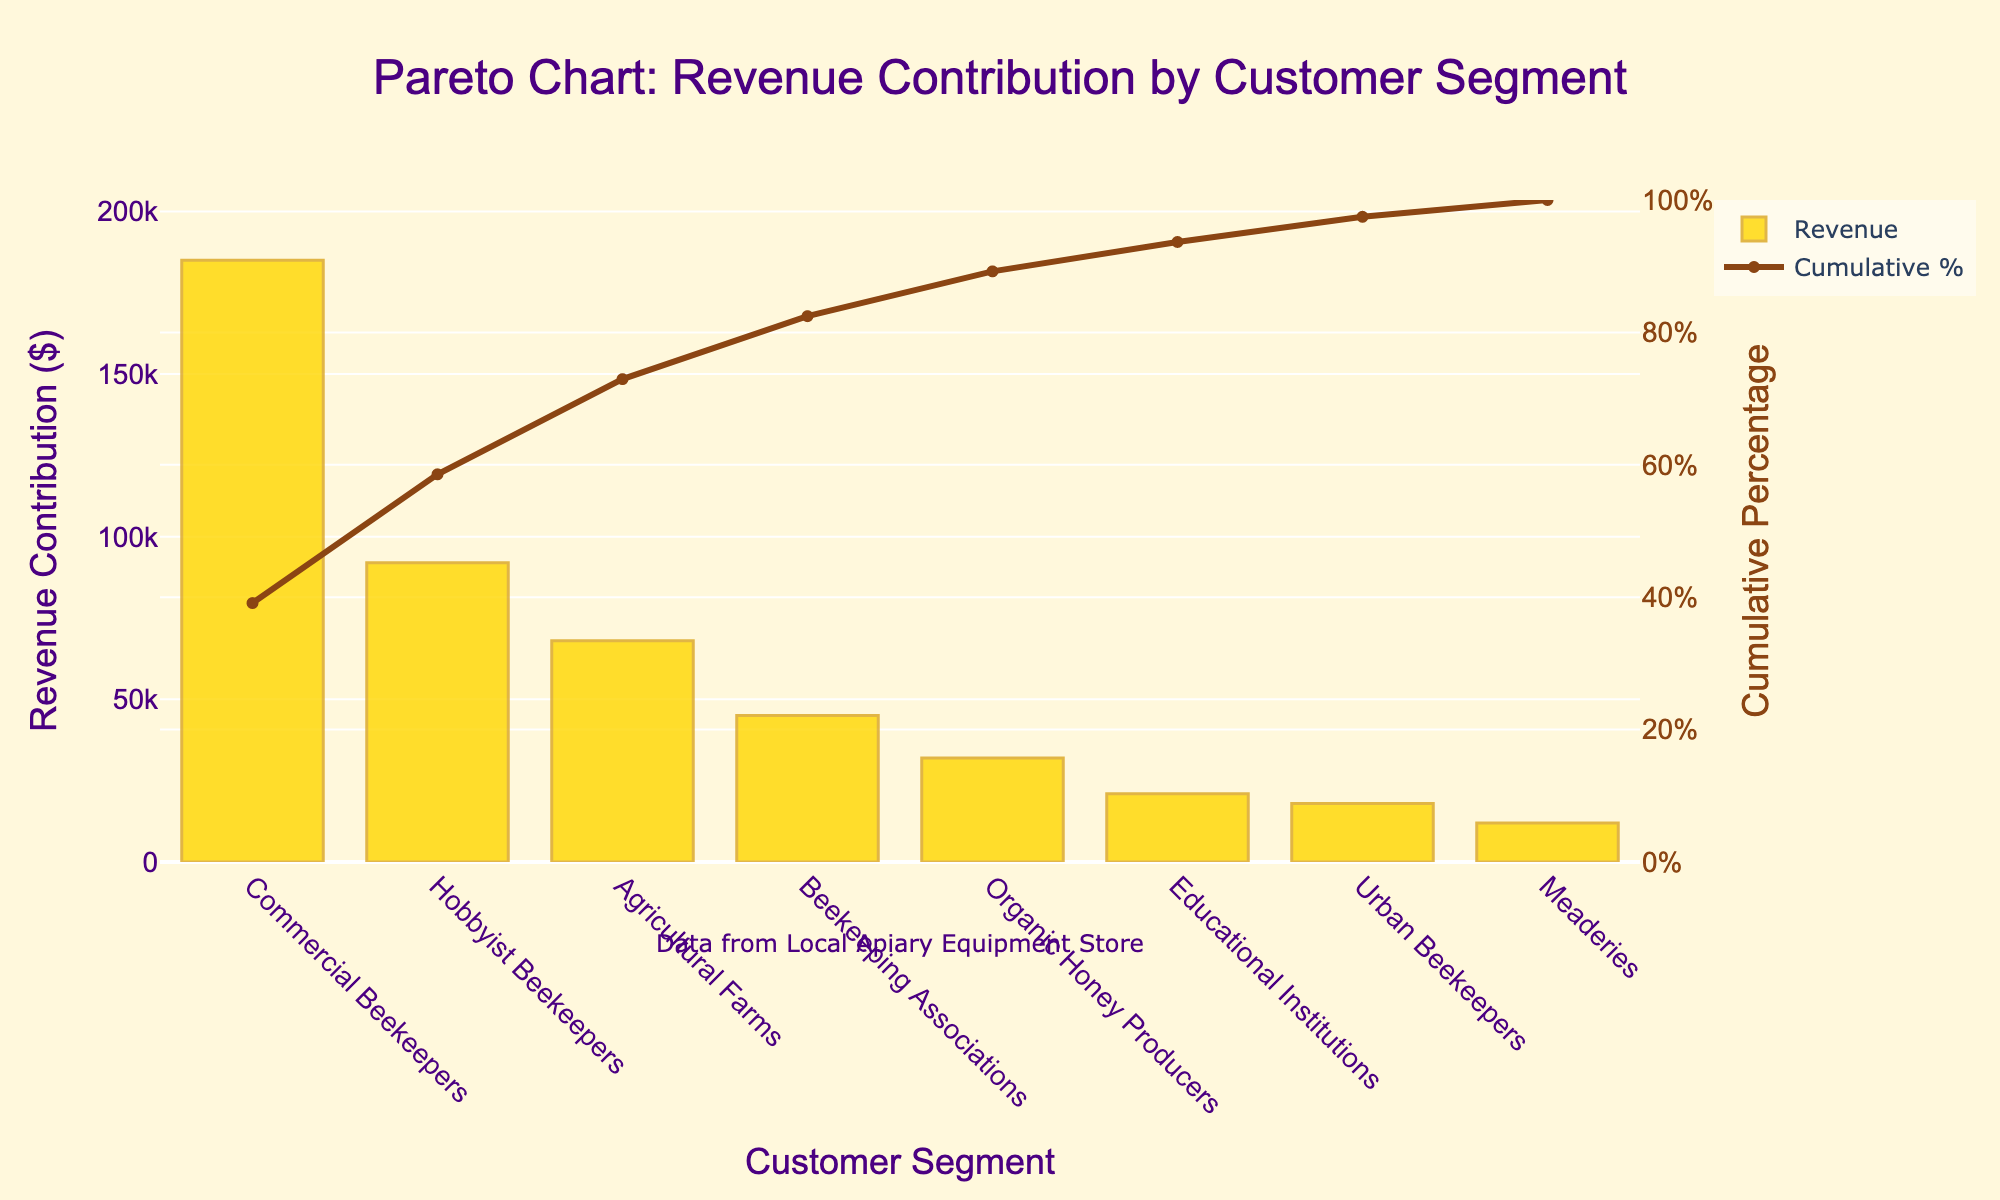How many customer segments are shown in the figure? Count the number of distinct bars in the chart. There are 8 bars representing different customer segments: Commercial Beekeepers, Hobbyist Beekeepers, Agricultural Farms, Beekeeping Associations, Organic Honey Producers, Educational Institutions, Urban Beekeepers, and Meaderies.
Answer: 8 Which customer segment contributes the highest revenue? Look at the bar with the highest value on the y-axis. The Commercial Beekeepers segment has the tallest bar, indicating the highest revenue contribution.
Answer: Commercial Beekeepers What is the cumulative percentage for the "Hobbyist Beekeepers" segment? Find the line corresponding to the "Hobbyist Beekeepers" bar and trace it to the right y-axis (Cumulative Percentage). The cumulative percentage is approximately 65%.
Answer: 65% What is the combined revenue contribution of "Agricultural Farms" and "Beekeeping Associations"? Sum the revenue contributions of both segments. Agricultural Farms contribute $68,000 and Beekeeping Associations contribute $45,000. Thus, the combined revenue is $68,000 + $45,000 = $113,000.
Answer: $113,000 Which segment has the lowest revenue contribution, and how much is it? Identify the bar with the lowest value on the y-axis. The Meaderies segment has the shortest bar with a revenue contribution of $12,000.
Answer: Meaderies, $12,000 What is the percentage difference in cumulative percentage from "Organic Honey Producers" to "Educational Institutions"? Find the cumulative percentages at these two points and subtract one from the other. Organic Honey Producers are at approximately 89%, and Educational Institutions are at approximately 97%. The difference is 97% - 89% = 8%.
Answer: 8% How much more revenue do "Commercial Beekeepers" generate compared to "Urban Beekeepers"? Subtract the revenue contribution of Urban Beekeepers from that of Commercial Beekeepers. Commercial Beekeepers contribute $185,000 while Urban Beekeepers contribute $18,000. The difference is $185,000 - $18,000 = $167,000.
Answer: $167,000 What is the total revenue contribution from all the customer segments? Sum all the revenue contributions from each segment. $185,000 + $92,000 + $68,000 + $45,000 + $32,000 + $21,000 + $18,000 + $12,000 = $473,000.
Answer: $473,000 What is the cumulative percentage contributed by the top three segments? Sum the cumulative percentages of the top three segments or their contributions and divide by the total revenue. Commercial Beekeepers, Hobbyist Beekeepers, and Agricultural Farms together account for $185,000 + $92,000 + $68,000 = $345,000. The cumulative percentage is ($345,000 / $473,000) * 100 ≈ 73%.
Answer: 73% Which customer segment marks the point where cumulative revenue contribution exceeds 90%? Follow the cumulative percentage line up to the point where it crosses 90% on the right y-axis. This occurs between Organic Honey Producers and Educational Institutions, indicating they collectively surpass 90%.
Answer: Educational Institutions 